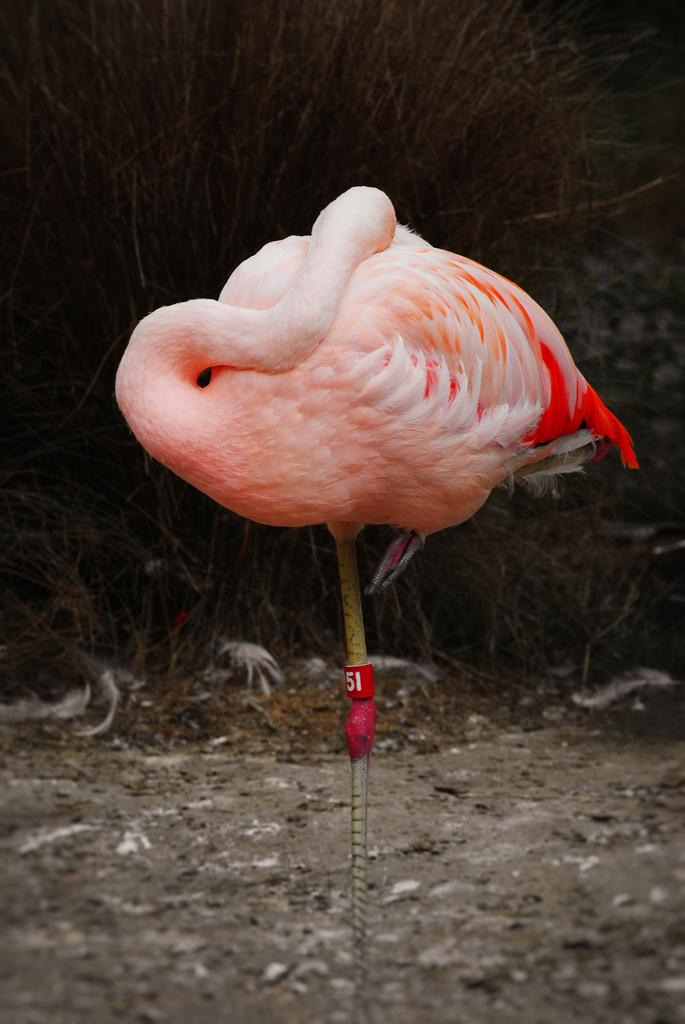What type of bird can be seen in the image? There is a pink color bird in the image. Where is the bird located in the image? The bird is standing on the ground. What can be seen in the background of the image? There are feathers in the background of the image. How would you describe the overall lighting in the image? The background of the image is dark. How many chairs are visible in the image? There are no chairs present in the image. What type of bushes can be seen in the image? There are no bushes present in the image. 